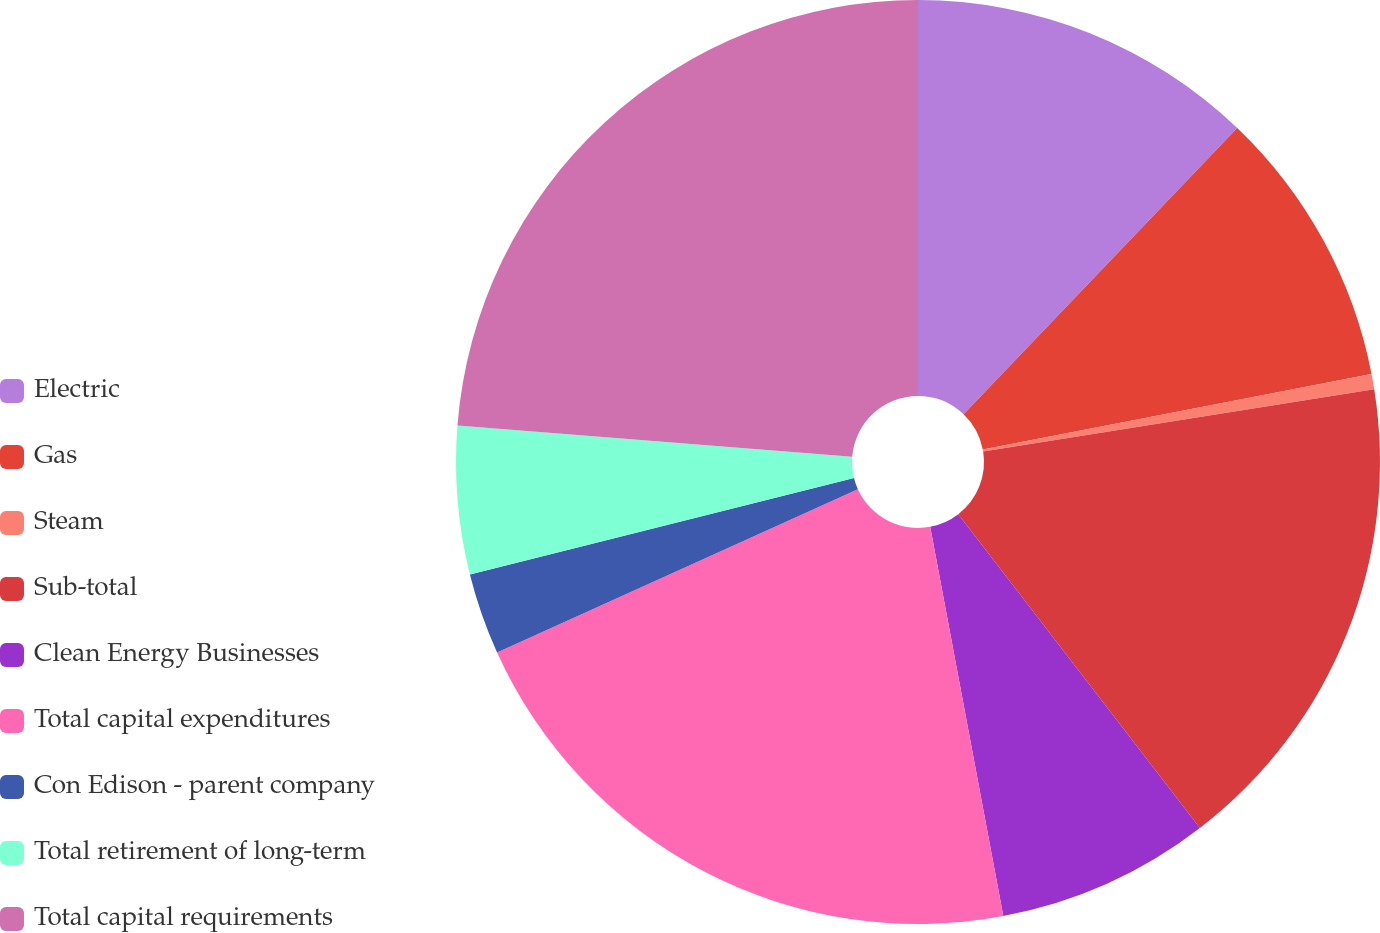Convert chart to OTSL. <chart><loc_0><loc_0><loc_500><loc_500><pie_chart><fcel>Electric<fcel>Gas<fcel>Steam<fcel>Sub-total<fcel>Clean Energy Businesses<fcel>Total capital expenditures<fcel>Con Edison - parent company<fcel>Total retirement of long-term<fcel>Total capital requirements<nl><fcel>12.14%<fcel>9.81%<fcel>0.53%<fcel>17.07%<fcel>7.49%<fcel>21.19%<fcel>2.85%<fcel>5.17%<fcel>23.74%<nl></chart> 